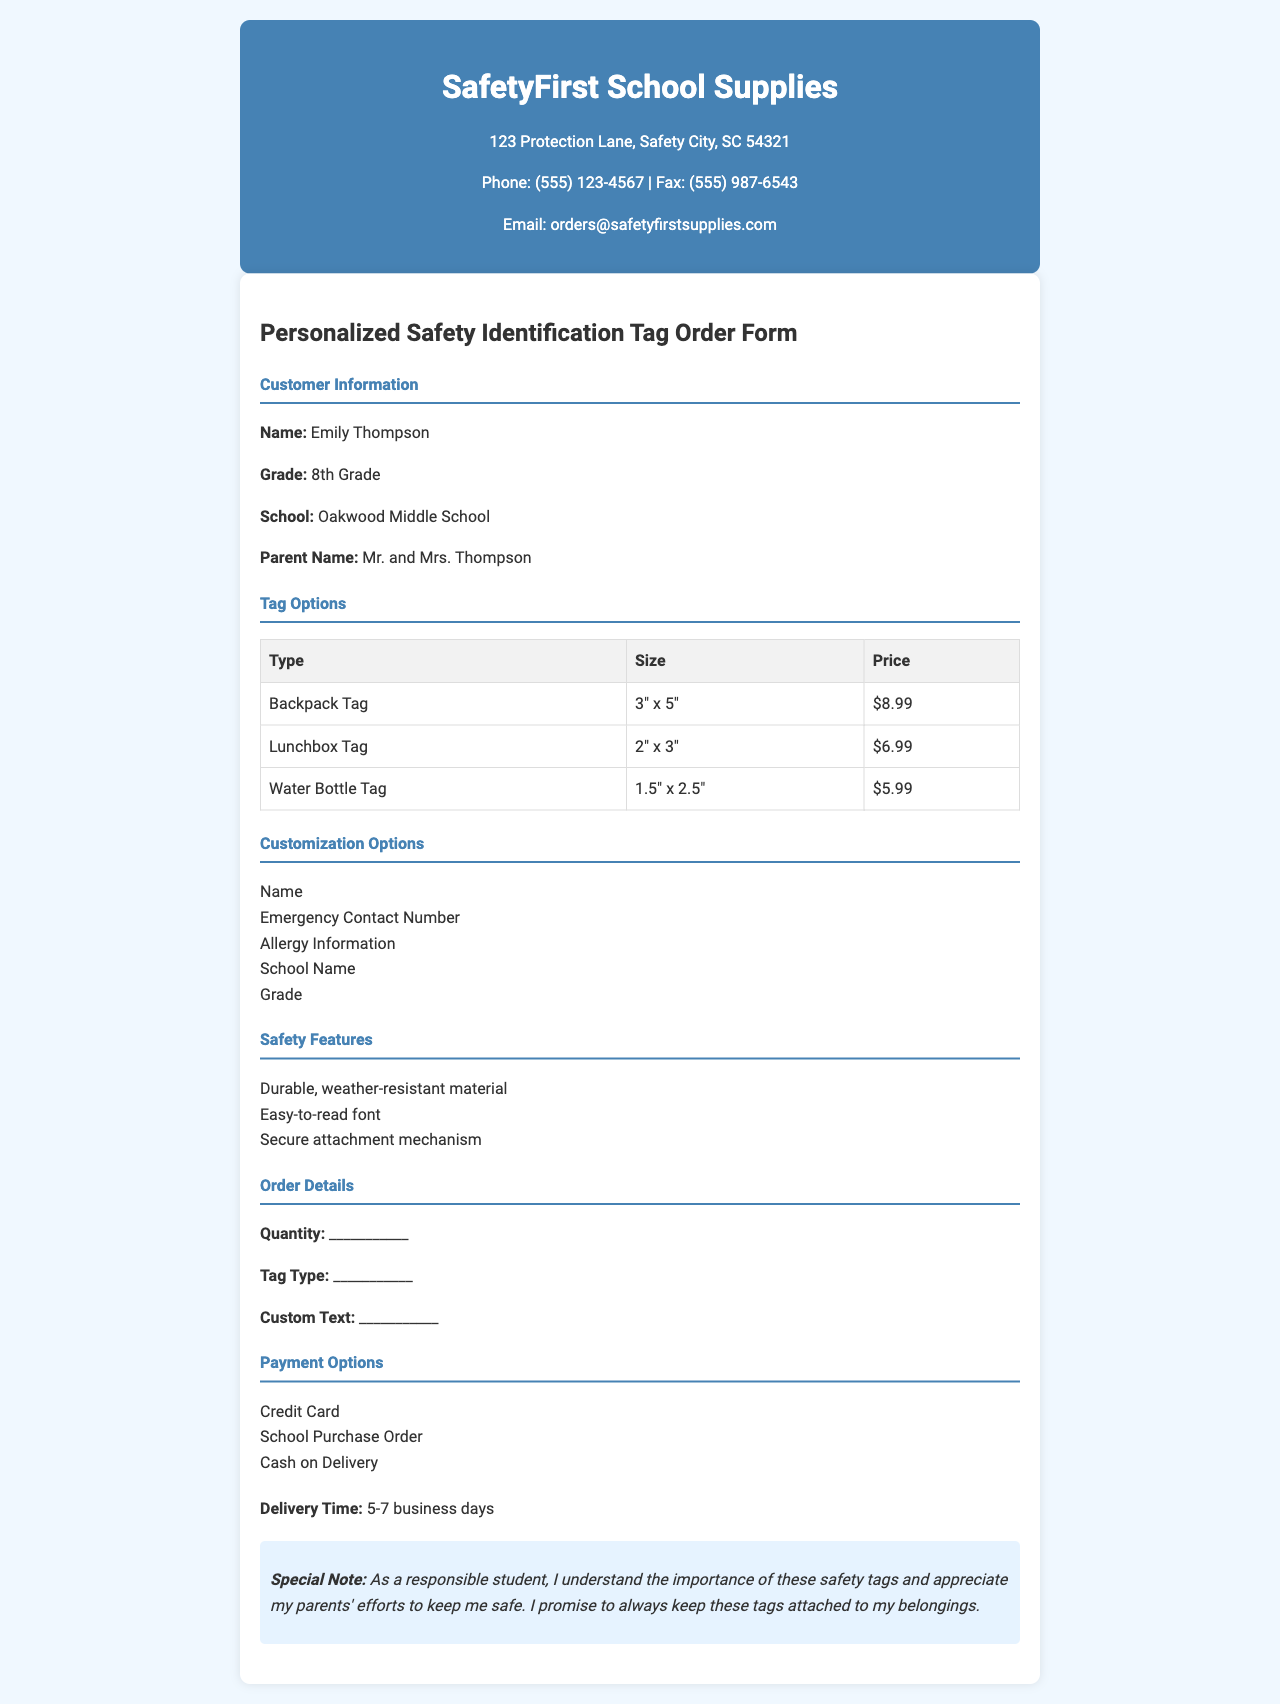What is the company name? The company name is mentioned at the top of the document.
Answer: SafetyFirst School Supplies What is the price of a Lunchbox Tag? The price is listed in the Tag Options table.
Answer: $6.99 What grade is Emily Thompson in? The grade of Emily Thompson is specified in the Customer Information section.
Answer: 8th Grade What is one of the customization options available? Customization options are listed in the document.
Answer: Name How long is the delivery time? The delivery time is mentioned in the Order Details section.
Answer: 5-7 business days What is a feature of the safety tags? Safety features are listed in the document.
Answer: Durable, weather-resistant material What special note is included in the document? The special note can be found in the designated section at the end of the document.
Answer: As a responsible student, I understand the importance of these safety tags and appreciate my parents' efforts to keep me safe. I promise to always keep these tags attached to my belongings 